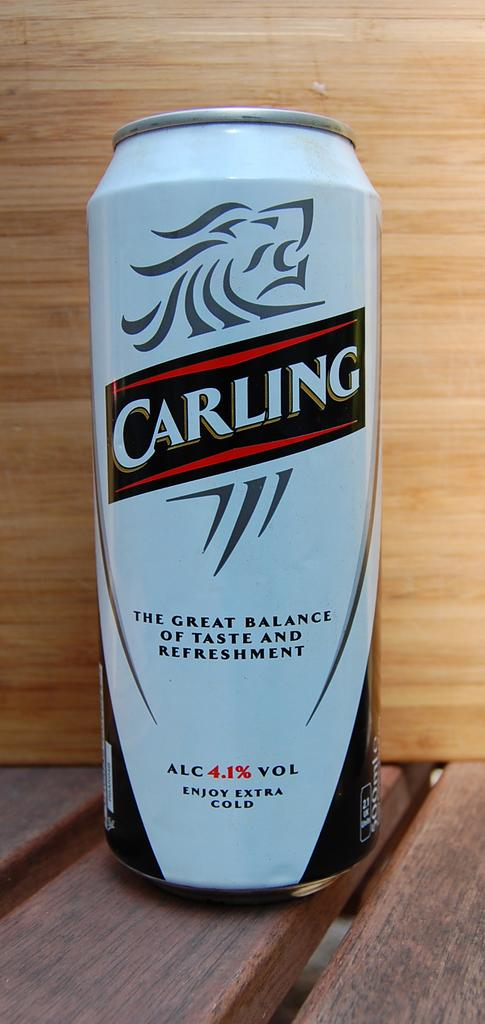<image>
Share a concise interpretation of the image provided. a white can of Carling has an alcohol content of 4.1 